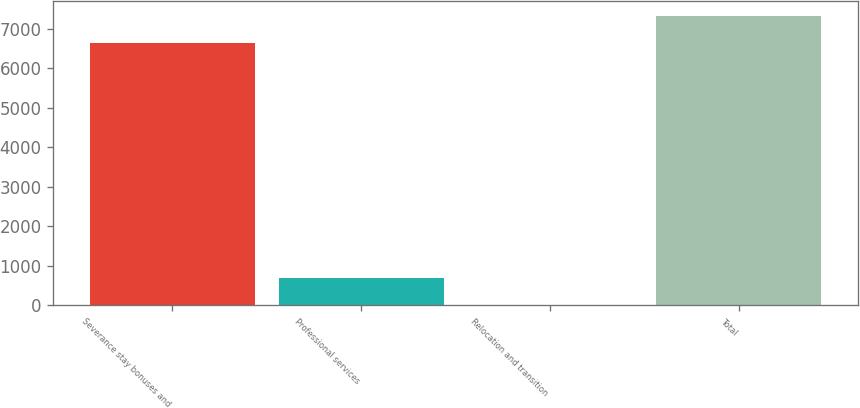<chart> <loc_0><loc_0><loc_500><loc_500><bar_chart><fcel>Severance stay bonuses and<fcel>Professional services<fcel>Relocation and transition<fcel>Total<nl><fcel>6650<fcel>703<fcel>20<fcel>7333<nl></chart> 